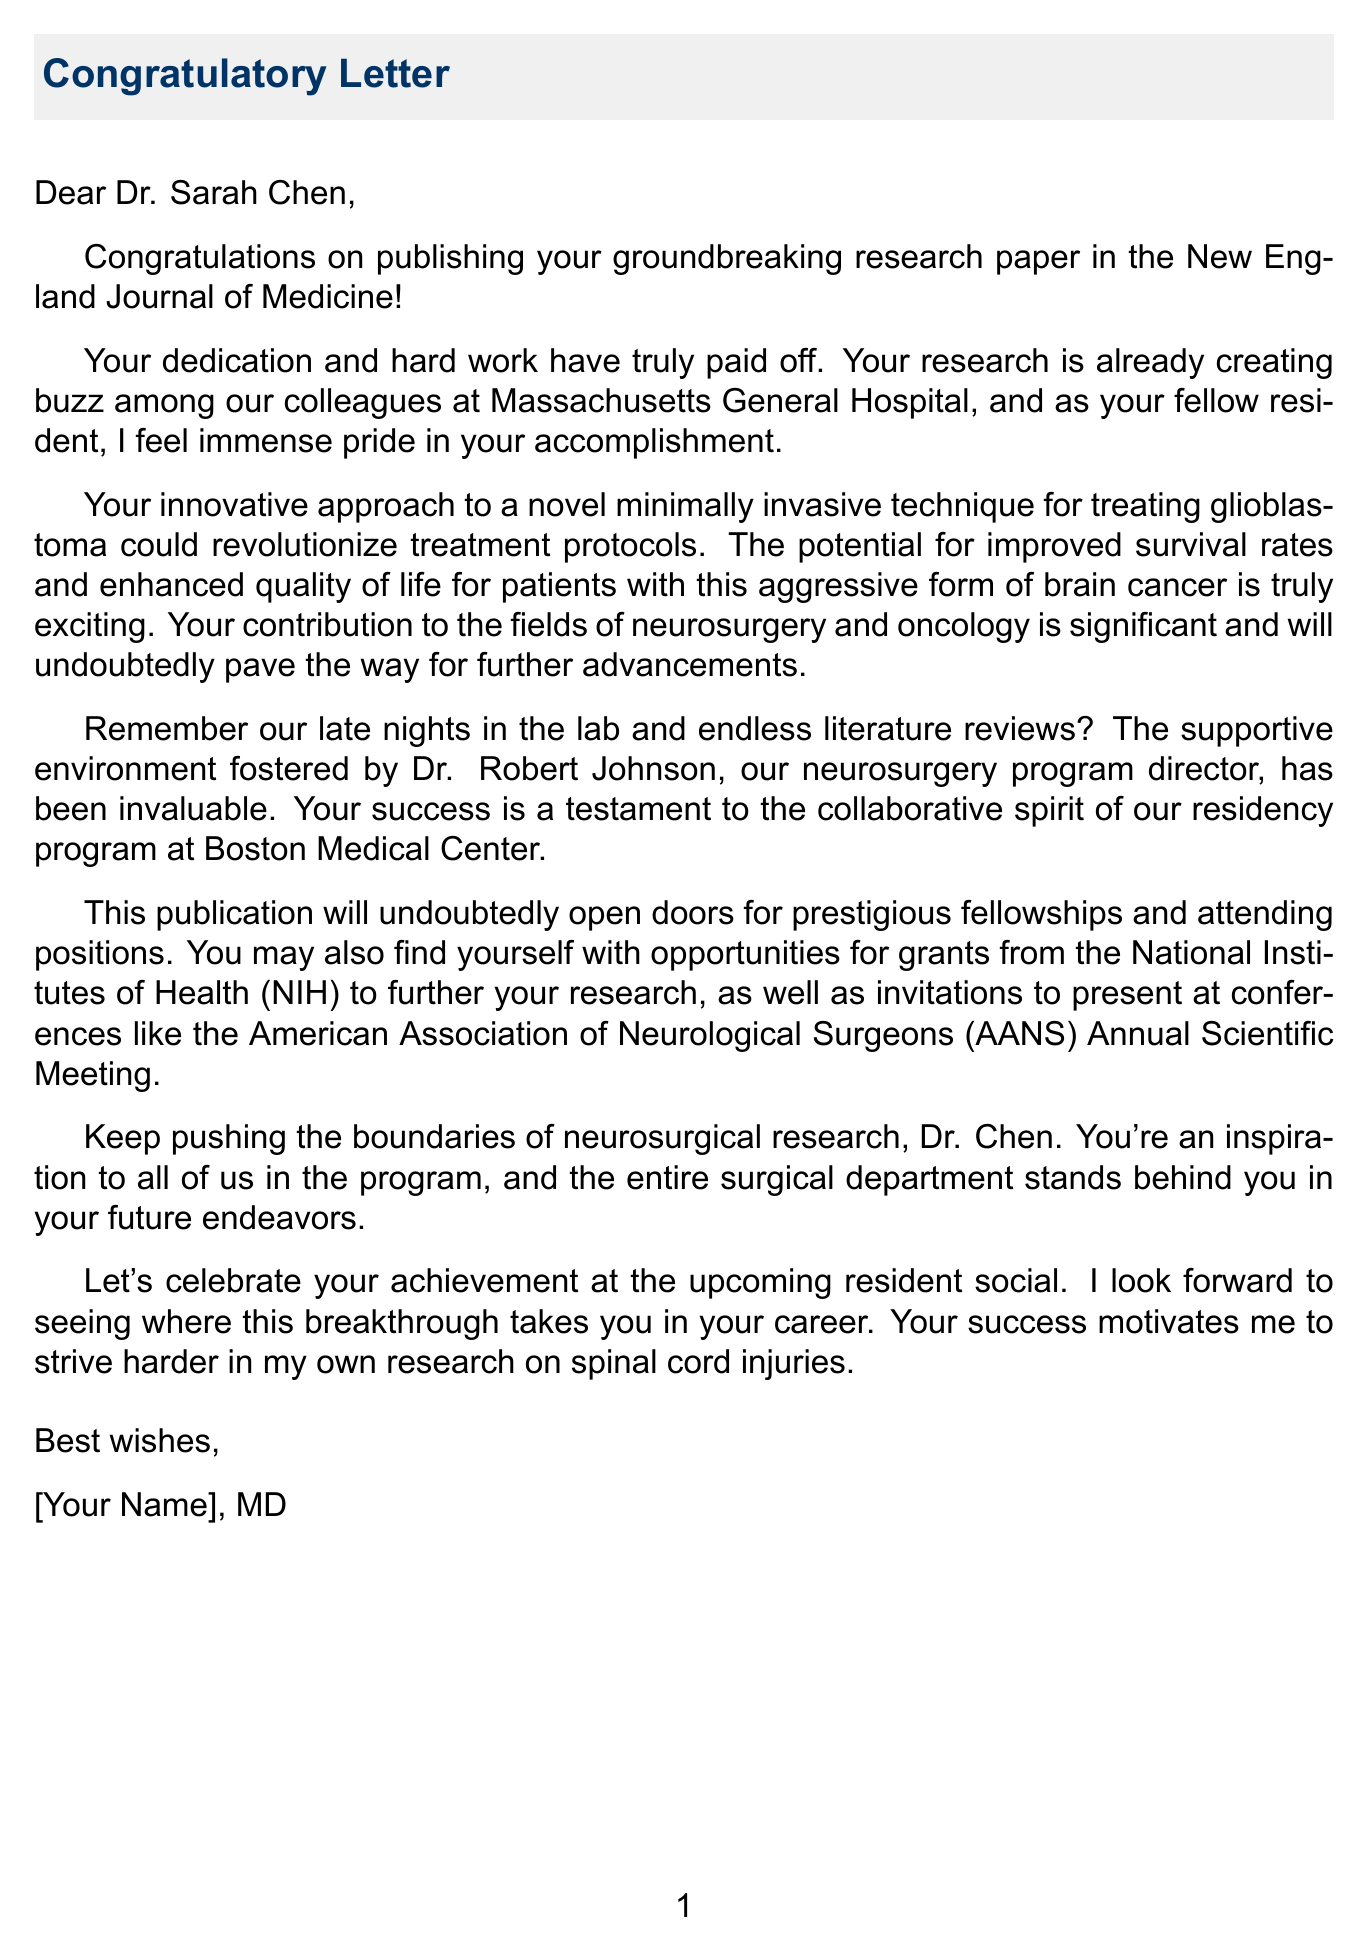What is the recipient's name? The recipient's name is explicitly stated in the greeting of the letter.
Answer: Dr. Sarah Chen What is the title of the published research paper? The title is mentioned in the opening statement of the letter, highlighting the accomplishment.
Answer: Novel minimally invasive approach for treating glioblastoma Which journal published the research paper? The specific journal is mentioned directly after the accomplishment in the opening statement.
Answer: New England Journal of Medicine Who is recognized for their mentorship? The letter mentions a person who provided valuable support to the recipient.
Answer: Dr. Robert Johnson What is one potential benefit of the recipient's research? The document provides specific examples of the impact of the research on patient outcomes.
Answer: Improved survival rates What event is suggested for celebrating the recipient's accomplishment? The letter mentions an upcoming social event to celebrate the achievement.
Answer: Resident social What field does the recipient's research contribute to? The document notes the areas impacted by the recipient's innovative approach.
Answer: Neurosurgery and oncology How does the letter's author feel about the recipient's success? The author's pride reflects their personal feelings towards the accomplishment described in the document.
Answer: Immense pride 